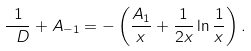<formula> <loc_0><loc_0><loc_500><loc_500>\frac { 1 } { \ D } + A _ { - 1 } = - \left ( \frac { A _ { 1 } } { x } + \frac { 1 } { 2 x } \ln \frac { 1 } { x } \right ) .</formula> 